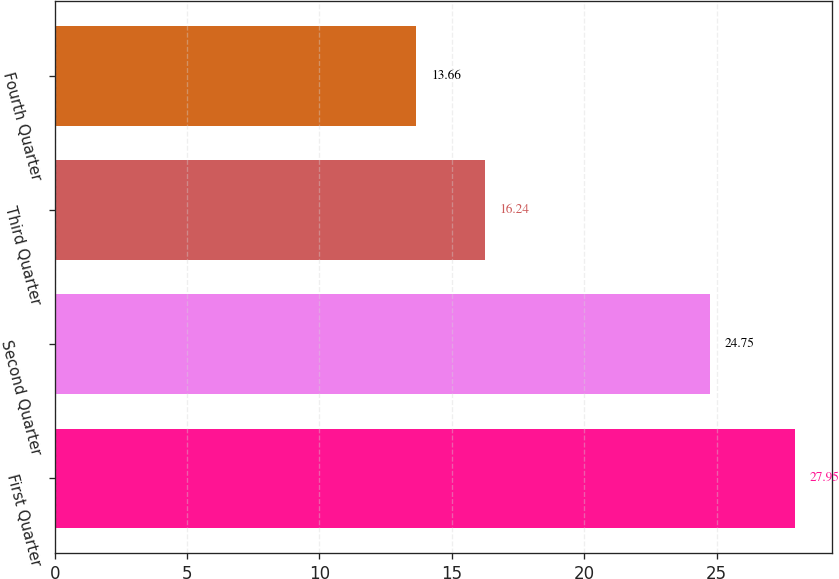<chart> <loc_0><loc_0><loc_500><loc_500><bar_chart><fcel>First Quarter<fcel>Second Quarter<fcel>Third Quarter<fcel>Fourth Quarter<nl><fcel>27.95<fcel>24.75<fcel>16.24<fcel>13.66<nl></chart> 